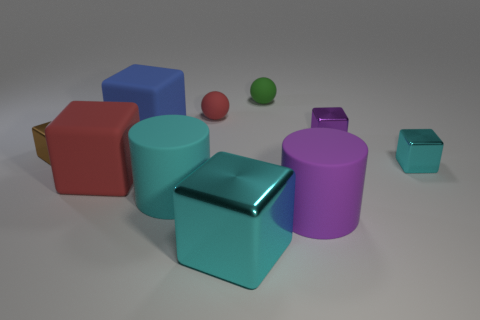What number of things are things on the left side of the small cyan cube or large matte cylinders?
Give a very brief answer. 9. What number of small red things are there?
Offer a very short reply. 1. The big purple thing that is the same material as the large blue object is what shape?
Give a very brief answer. Cylinder. There is a rubber object that is in front of the cyan rubber cylinder that is behind the big purple thing; how big is it?
Offer a terse response. Large. How many objects are red objects in front of the small purple metal block or red matte objects on the right side of the cyan matte cylinder?
Provide a short and direct response. 2. Is the number of big brown objects less than the number of purple rubber objects?
Give a very brief answer. Yes. How many objects are tiny cyan shiny things or purple rubber cylinders?
Your answer should be very brief. 2. Is the shape of the large cyan shiny thing the same as the cyan rubber object?
Make the answer very short. No. Is there any other thing that is the same material as the big purple cylinder?
Provide a succinct answer. Yes. There is a red rubber object in front of the tiny cyan shiny cube; is its size the same as the shiny block that is in front of the tiny cyan cube?
Provide a succinct answer. Yes. 